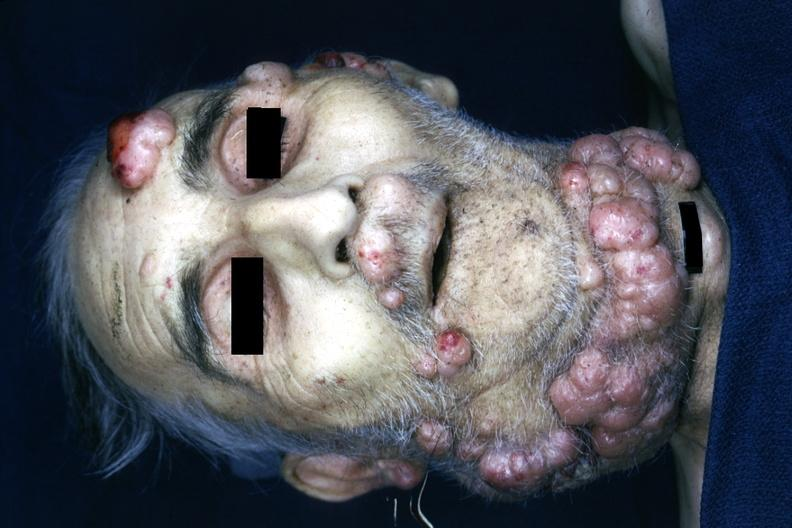s disease present?
Answer the question using a single word or phrase. Yes 